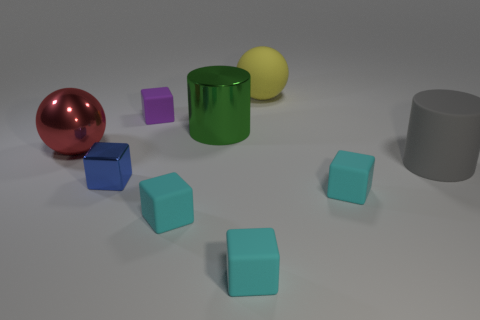Do the blue shiny thing and the tiny object behind the blue object have the same shape?
Offer a very short reply. Yes. There is a big thing that is both in front of the purple object and to the right of the big green shiny thing; what is its color?
Your answer should be compact. Gray. What material is the cyan object left of the metal thing right of the block behind the big gray rubber thing?
Offer a terse response. Rubber. What material is the red thing?
Give a very brief answer. Metal. There is a purple object that is the same shape as the small blue shiny object; what size is it?
Your response must be concise. Small. Is the metallic ball the same color as the shiny block?
Provide a short and direct response. No. How many other things are the same material as the gray cylinder?
Give a very brief answer. 5. Is the number of yellow matte spheres that are in front of the blue metallic object the same as the number of large yellow rubber spheres?
Your answer should be very brief. No. Does the block on the left side of the purple matte object have the same size as the rubber cylinder?
Provide a short and direct response. No. What number of big rubber things are in front of the small blue metal cube?
Your answer should be very brief. 0. 